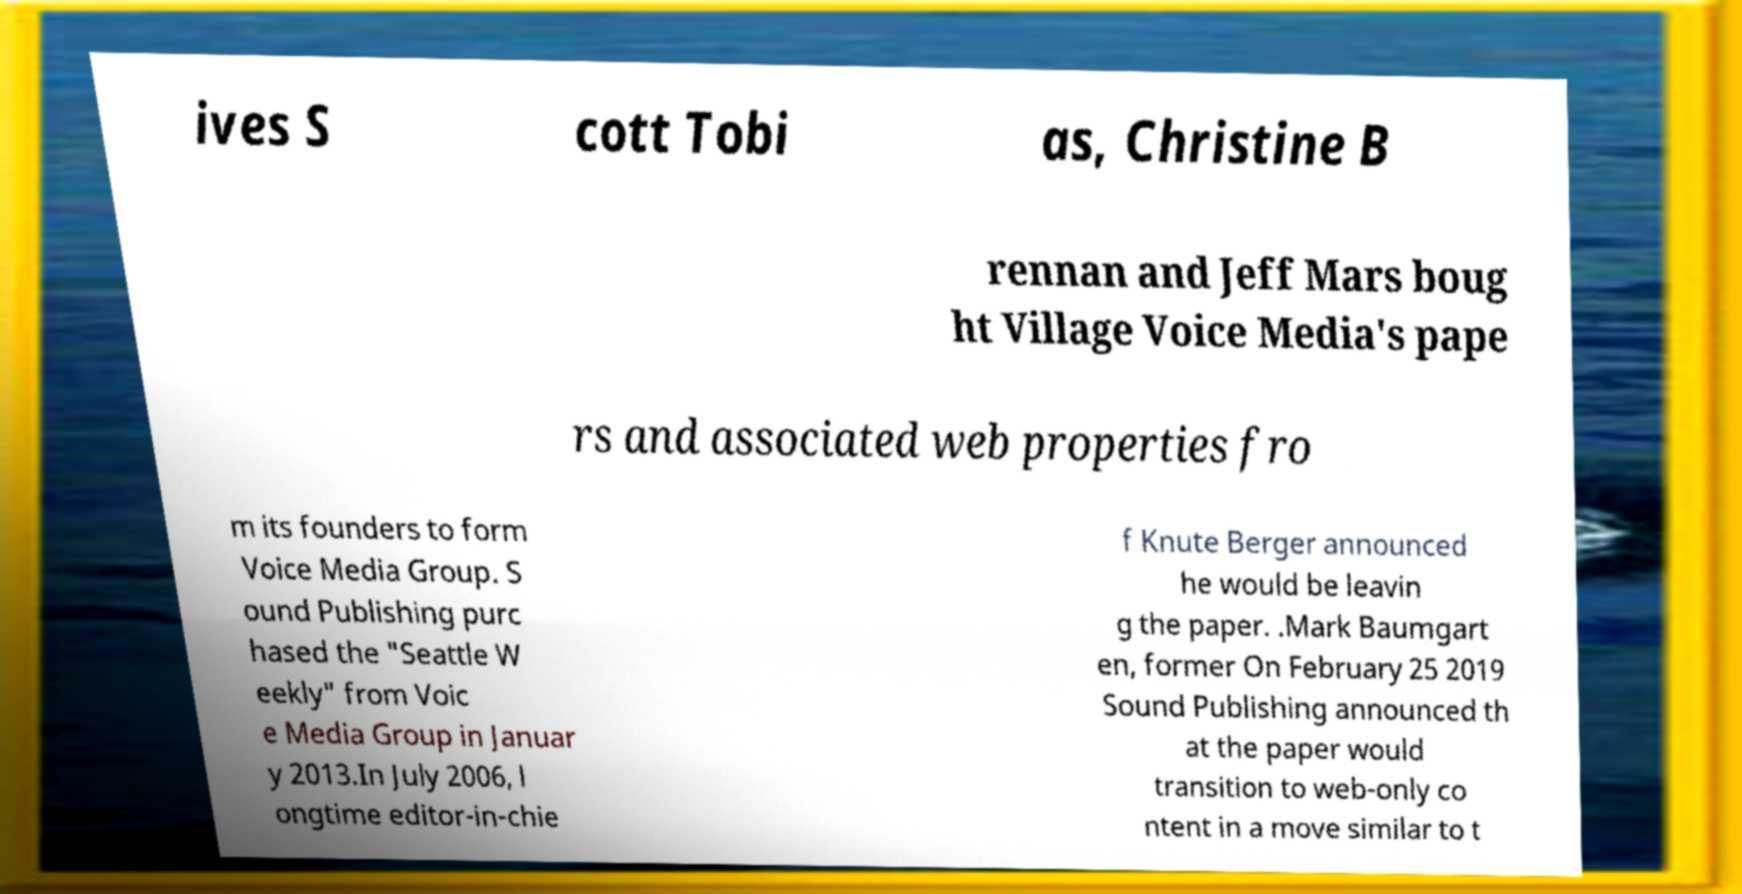I need the written content from this picture converted into text. Can you do that? ives S cott Tobi as, Christine B rennan and Jeff Mars boug ht Village Voice Media's pape rs and associated web properties fro m its founders to form Voice Media Group. S ound Publishing purc hased the "Seattle W eekly" from Voic e Media Group in Januar y 2013.In July 2006, l ongtime editor-in-chie f Knute Berger announced he would be leavin g the paper. .Mark Baumgart en, former On February 25 2019 Sound Publishing announced th at the paper would transition to web-only co ntent in a move similar to t 